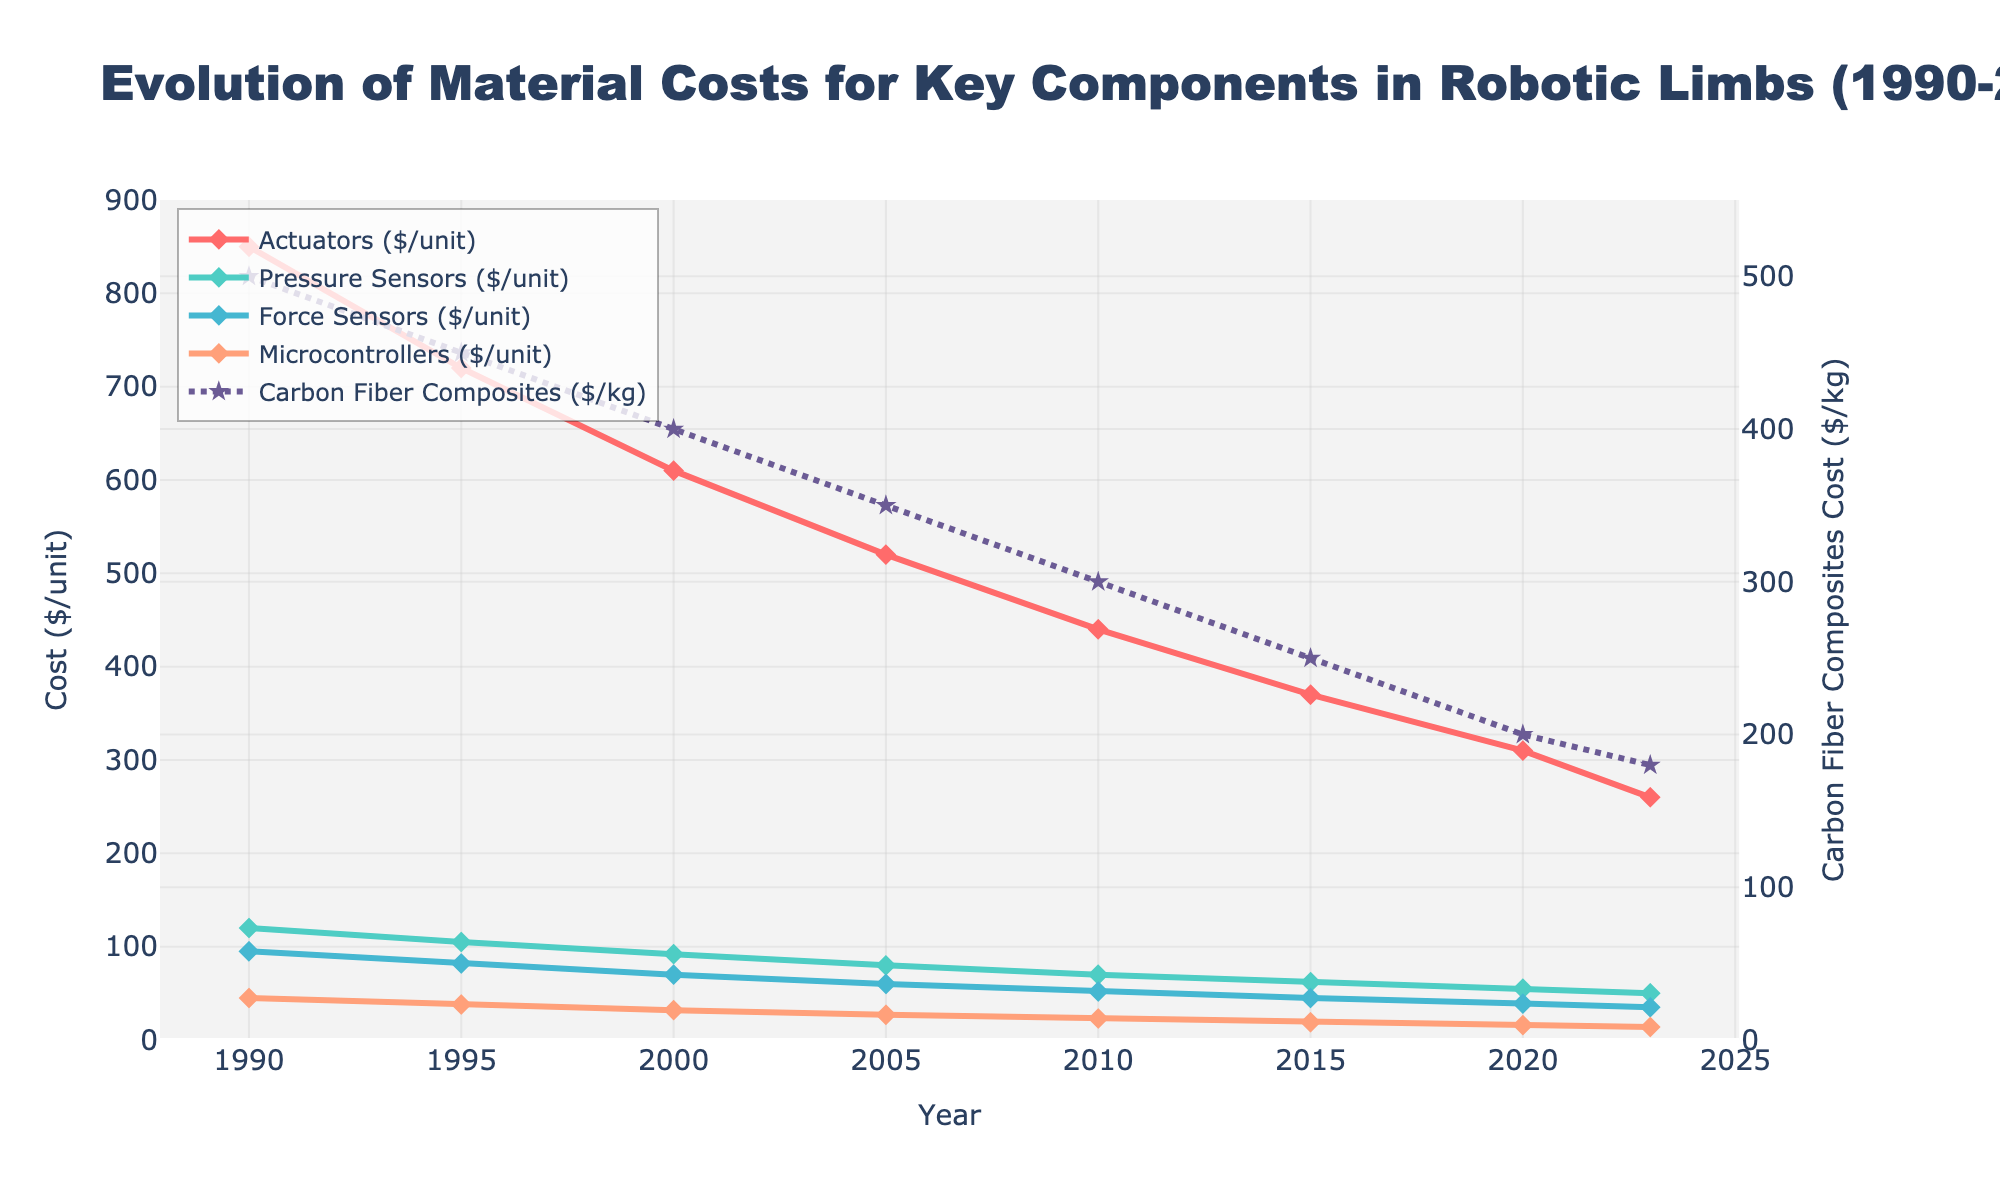What trend can you observe for the cost of actuators over time? The cost of actuators shows a decreasing trend as the years progress. Starting from 1990 at $850/unit and gradually reducing to $260/unit by 2023.
Answer: Decreasing By how much did the cost of Carbon Fiber Composites decrease between 2000 and 2023? The cost in 2000 was $400/kg and in 2023 was $180/kg. The decrease is $400 - $180 = $220.
Answer: $220 Compare the trends of Pressure Sensors and Force Sensors costs over the years. Both Pressure Sensors and Force Sensors show a decreasing trend starting from higher values in 1990 and reducing over time. By 2023, the costs of both components have significantly dropped. The decline is steady for both components, though the cost of Pressure Sensors is consistently higher than that of Force Sensors from 1990 to 2023.
Answer: Both decreasing, Pressure Sensors consistently higher What has been the overall trend in the cost of Microcontrollers from 1990 to 2023? The cost of Microcontrollers shows a decreasing trend over the years, from $45/unit in 1990 to $14/unit in 2023. This reduction has been steady over each subsequent five-year period.
Answer: Decreasing Which year had the biggest drop in cost for Force Sensors? By observing the plot, the biggest drop in the cost of Force Sensors appears between 1995 ($82/unit) and 2000 ($70/unit), a decrease of $12.
Answer: 1995-2000 How do the trends of Actuators and Carbon Fiber Composites compare? Both Actuators and Carbon Fiber Composites show a decreasing trend over the years. However, Actuators' costs decrease more steeply compared to the costs of Carbon Fiber Composites. Additionally, even though both start high and end lower, Carbon Fiber Composites are plotted on a different y-axis due to differing units and scale.
Answer: Both decreasing, Actuators more steeply 